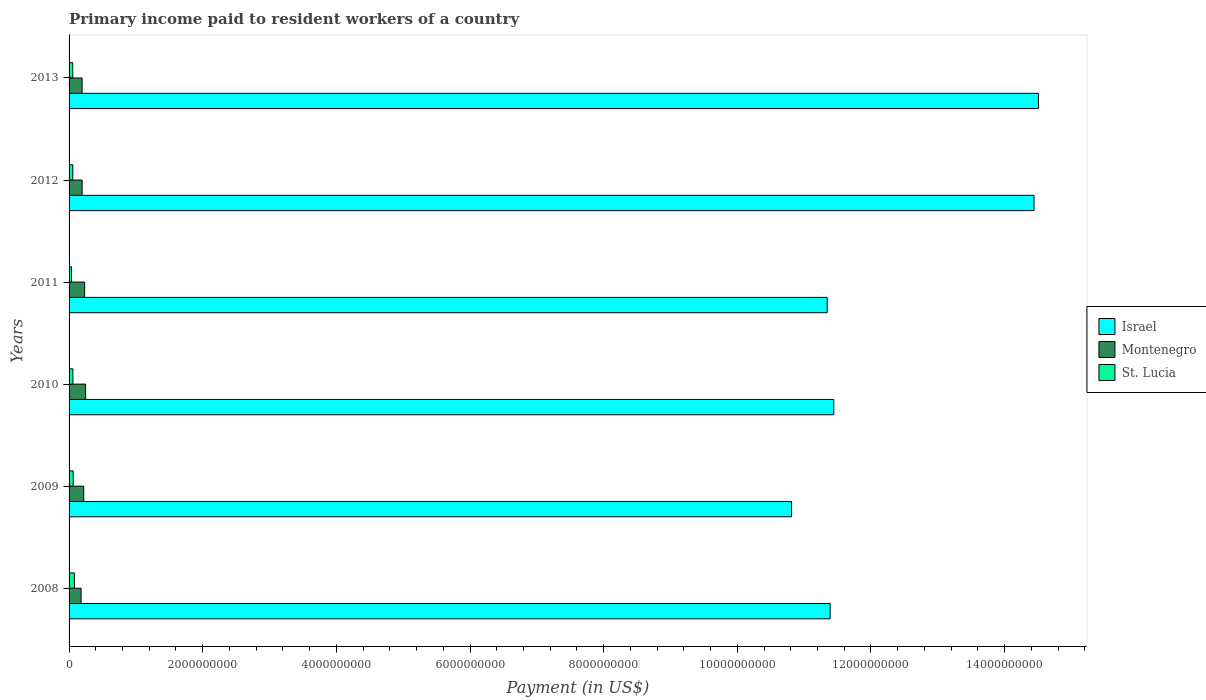How many different coloured bars are there?
Offer a very short reply. 3. How many groups of bars are there?
Your response must be concise. 6. Are the number of bars per tick equal to the number of legend labels?
Give a very brief answer. Yes. Are the number of bars on each tick of the Y-axis equal?
Provide a short and direct response. Yes. How many bars are there on the 3rd tick from the top?
Give a very brief answer. 3. In how many cases, is the number of bars for a given year not equal to the number of legend labels?
Offer a very short reply. 0. What is the amount paid to workers in St. Lucia in 2009?
Your answer should be compact. 6.17e+07. Across all years, what is the maximum amount paid to workers in Montenegro?
Offer a terse response. 2.47e+08. Across all years, what is the minimum amount paid to workers in St. Lucia?
Ensure brevity in your answer.  3.61e+07. In which year was the amount paid to workers in Montenegro maximum?
Offer a terse response. 2010. In which year was the amount paid to workers in St. Lucia minimum?
Give a very brief answer. 2011. What is the total amount paid to workers in St. Lucia in the graph?
Make the answer very short. 3.46e+08. What is the difference between the amount paid to workers in Montenegro in 2008 and that in 2011?
Give a very brief answer. -5.30e+07. What is the difference between the amount paid to workers in St. Lucia in 2011 and the amount paid to workers in Montenegro in 2012?
Provide a short and direct response. -1.59e+08. What is the average amount paid to workers in Israel per year?
Offer a very short reply. 1.23e+1. In the year 2012, what is the difference between the amount paid to workers in Israel and amount paid to workers in St. Lucia?
Give a very brief answer. 1.44e+1. In how many years, is the amount paid to workers in St. Lucia greater than 5600000000 US$?
Your answer should be compact. 0. What is the ratio of the amount paid to workers in Israel in 2011 to that in 2012?
Provide a short and direct response. 0.79. Is the amount paid to workers in St. Lucia in 2010 less than that in 2011?
Provide a short and direct response. No. What is the difference between the highest and the second highest amount paid to workers in St. Lucia?
Provide a short and direct response. 1.84e+07. What is the difference between the highest and the lowest amount paid to workers in Israel?
Your answer should be compact. 3.70e+09. In how many years, is the amount paid to workers in St. Lucia greater than the average amount paid to workers in St. Lucia taken over all years?
Offer a very short reply. 2. Is the sum of the amount paid to workers in Montenegro in 2008 and 2011 greater than the maximum amount paid to workers in St. Lucia across all years?
Make the answer very short. Yes. What does the 2nd bar from the top in 2013 represents?
Provide a succinct answer. Montenegro. What does the 2nd bar from the bottom in 2012 represents?
Your answer should be compact. Montenegro. Is it the case that in every year, the sum of the amount paid to workers in Montenegro and amount paid to workers in St. Lucia is greater than the amount paid to workers in Israel?
Provide a succinct answer. No. How many bars are there?
Ensure brevity in your answer.  18. How many years are there in the graph?
Offer a very short reply. 6. What is the difference between two consecutive major ticks on the X-axis?
Your answer should be very brief. 2.00e+09. Are the values on the major ticks of X-axis written in scientific E-notation?
Ensure brevity in your answer.  No. Does the graph contain any zero values?
Provide a short and direct response. No. Does the graph contain grids?
Your answer should be compact. No. How are the legend labels stacked?
Your response must be concise. Vertical. What is the title of the graph?
Ensure brevity in your answer.  Primary income paid to resident workers of a country. Does "Uruguay" appear as one of the legend labels in the graph?
Keep it short and to the point. No. What is the label or title of the X-axis?
Ensure brevity in your answer.  Payment (in US$). What is the label or title of the Y-axis?
Provide a short and direct response. Years. What is the Payment (in US$) of Israel in 2008?
Provide a short and direct response. 1.14e+1. What is the Payment (in US$) in Montenegro in 2008?
Your response must be concise. 1.80e+08. What is the Payment (in US$) of St. Lucia in 2008?
Offer a terse response. 8.01e+07. What is the Payment (in US$) of Israel in 2009?
Offer a terse response. 1.08e+1. What is the Payment (in US$) in Montenegro in 2009?
Provide a short and direct response. 2.20e+08. What is the Payment (in US$) of St. Lucia in 2009?
Offer a terse response. 6.17e+07. What is the Payment (in US$) of Israel in 2010?
Keep it short and to the point. 1.14e+1. What is the Payment (in US$) of Montenegro in 2010?
Provide a short and direct response. 2.47e+08. What is the Payment (in US$) in St. Lucia in 2010?
Give a very brief answer. 5.73e+07. What is the Payment (in US$) of Israel in 2011?
Give a very brief answer. 1.13e+1. What is the Payment (in US$) of Montenegro in 2011?
Ensure brevity in your answer.  2.33e+08. What is the Payment (in US$) in St. Lucia in 2011?
Offer a very short reply. 3.61e+07. What is the Payment (in US$) in Israel in 2012?
Make the answer very short. 1.44e+1. What is the Payment (in US$) in Montenegro in 2012?
Your response must be concise. 1.95e+08. What is the Payment (in US$) in St. Lucia in 2012?
Ensure brevity in your answer.  5.53e+07. What is the Payment (in US$) in Israel in 2013?
Your answer should be compact. 1.45e+1. What is the Payment (in US$) in Montenegro in 2013?
Your answer should be very brief. 1.95e+08. What is the Payment (in US$) of St. Lucia in 2013?
Your answer should be compact. 5.52e+07. Across all years, what is the maximum Payment (in US$) of Israel?
Your response must be concise. 1.45e+1. Across all years, what is the maximum Payment (in US$) in Montenegro?
Your response must be concise. 2.47e+08. Across all years, what is the maximum Payment (in US$) in St. Lucia?
Give a very brief answer. 8.01e+07. Across all years, what is the minimum Payment (in US$) of Israel?
Ensure brevity in your answer.  1.08e+1. Across all years, what is the minimum Payment (in US$) in Montenegro?
Provide a succinct answer. 1.80e+08. Across all years, what is the minimum Payment (in US$) of St. Lucia?
Your answer should be very brief. 3.61e+07. What is the total Payment (in US$) in Israel in the graph?
Provide a short and direct response. 7.39e+1. What is the total Payment (in US$) in Montenegro in the graph?
Provide a short and direct response. 1.27e+09. What is the total Payment (in US$) in St. Lucia in the graph?
Give a very brief answer. 3.46e+08. What is the difference between the Payment (in US$) in Israel in 2008 and that in 2009?
Offer a very short reply. 5.78e+08. What is the difference between the Payment (in US$) in Montenegro in 2008 and that in 2009?
Keep it short and to the point. -3.97e+07. What is the difference between the Payment (in US$) of St. Lucia in 2008 and that in 2009?
Provide a succinct answer. 1.84e+07. What is the difference between the Payment (in US$) in Israel in 2008 and that in 2010?
Keep it short and to the point. -5.44e+07. What is the difference between the Payment (in US$) in Montenegro in 2008 and that in 2010?
Give a very brief answer. -6.74e+07. What is the difference between the Payment (in US$) of St. Lucia in 2008 and that in 2010?
Your response must be concise. 2.28e+07. What is the difference between the Payment (in US$) in Israel in 2008 and that in 2011?
Provide a short and direct response. 4.39e+07. What is the difference between the Payment (in US$) in Montenegro in 2008 and that in 2011?
Offer a terse response. -5.30e+07. What is the difference between the Payment (in US$) of St. Lucia in 2008 and that in 2011?
Your answer should be very brief. 4.40e+07. What is the difference between the Payment (in US$) in Israel in 2008 and that in 2012?
Your answer should be compact. -3.05e+09. What is the difference between the Payment (in US$) in Montenegro in 2008 and that in 2012?
Provide a short and direct response. -1.53e+07. What is the difference between the Payment (in US$) in St. Lucia in 2008 and that in 2012?
Give a very brief answer. 2.48e+07. What is the difference between the Payment (in US$) of Israel in 2008 and that in 2013?
Your response must be concise. -3.12e+09. What is the difference between the Payment (in US$) of Montenegro in 2008 and that in 2013?
Give a very brief answer. -1.51e+07. What is the difference between the Payment (in US$) in St. Lucia in 2008 and that in 2013?
Your answer should be compact. 2.49e+07. What is the difference between the Payment (in US$) of Israel in 2009 and that in 2010?
Provide a succinct answer. -6.32e+08. What is the difference between the Payment (in US$) of Montenegro in 2009 and that in 2010?
Offer a very short reply. -2.77e+07. What is the difference between the Payment (in US$) in St. Lucia in 2009 and that in 2010?
Your answer should be compact. 4.39e+06. What is the difference between the Payment (in US$) of Israel in 2009 and that in 2011?
Your answer should be compact. -5.34e+08. What is the difference between the Payment (in US$) of Montenegro in 2009 and that in 2011?
Offer a very short reply. -1.33e+07. What is the difference between the Payment (in US$) of St. Lucia in 2009 and that in 2011?
Your answer should be compact. 2.56e+07. What is the difference between the Payment (in US$) of Israel in 2009 and that in 2012?
Make the answer very short. -3.63e+09. What is the difference between the Payment (in US$) in Montenegro in 2009 and that in 2012?
Keep it short and to the point. 2.44e+07. What is the difference between the Payment (in US$) of St. Lucia in 2009 and that in 2012?
Make the answer very short. 6.37e+06. What is the difference between the Payment (in US$) in Israel in 2009 and that in 2013?
Offer a very short reply. -3.70e+09. What is the difference between the Payment (in US$) of Montenegro in 2009 and that in 2013?
Provide a short and direct response. 2.46e+07. What is the difference between the Payment (in US$) of St. Lucia in 2009 and that in 2013?
Provide a succinct answer. 6.50e+06. What is the difference between the Payment (in US$) in Israel in 2010 and that in 2011?
Provide a succinct answer. 9.83e+07. What is the difference between the Payment (in US$) in Montenegro in 2010 and that in 2011?
Give a very brief answer. 1.44e+07. What is the difference between the Payment (in US$) in St. Lucia in 2010 and that in 2011?
Your answer should be compact. 2.12e+07. What is the difference between the Payment (in US$) of Israel in 2010 and that in 2012?
Your answer should be very brief. -3.00e+09. What is the difference between the Payment (in US$) of Montenegro in 2010 and that in 2012?
Offer a very short reply. 5.21e+07. What is the difference between the Payment (in US$) in St. Lucia in 2010 and that in 2012?
Ensure brevity in your answer.  1.98e+06. What is the difference between the Payment (in US$) of Israel in 2010 and that in 2013?
Your answer should be compact. -3.06e+09. What is the difference between the Payment (in US$) of Montenegro in 2010 and that in 2013?
Your response must be concise. 5.23e+07. What is the difference between the Payment (in US$) in St. Lucia in 2010 and that in 2013?
Your answer should be very brief. 2.11e+06. What is the difference between the Payment (in US$) of Israel in 2011 and that in 2012?
Provide a short and direct response. -3.10e+09. What is the difference between the Payment (in US$) in Montenegro in 2011 and that in 2012?
Your answer should be very brief. 3.77e+07. What is the difference between the Payment (in US$) in St. Lucia in 2011 and that in 2012?
Your answer should be compact. -1.92e+07. What is the difference between the Payment (in US$) of Israel in 2011 and that in 2013?
Make the answer very short. -3.16e+09. What is the difference between the Payment (in US$) of Montenegro in 2011 and that in 2013?
Make the answer very short. 3.79e+07. What is the difference between the Payment (in US$) in St. Lucia in 2011 and that in 2013?
Provide a succinct answer. -1.91e+07. What is the difference between the Payment (in US$) of Israel in 2012 and that in 2013?
Your response must be concise. -6.60e+07. What is the difference between the Payment (in US$) of Montenegro in 2012 and that in 2013?
Your response must be concise. 2.12e+05. What is the difference between the Payment (in US$) in St. Lucia in 2012 and that in 2013?
Ensure brevity in your answer.  1.30e+05. What is the difference between the Payment (in US$) of Israel in 2008 and the Payment (in US$) of Montenegro in 2009?
Your answer should be compact. 1.12e+1. What is the difference between the Payment (in US$) of Israel in 2008 and the Payment (in US$) of St. Lucia in 2009?
Give a very brief answer. 1.13e+1. What is the difference between the Payment (in US$) in Montenegro in 2008 and the Payment (in US$) in St. Lucia in 2009?
Offer a terse response. 1.18e+08. What is the difference between the Payment (in US$) of Israel in 2008 and the Payment (in US$) of Montenegro in 2010?
Ensure brevity in your answer.  1.11e+1. What is the difference between the Payment (in US$) of Israel in 2008 and the Payment (in US$) of St. Lucia in 2010?
Provide a succinct answer. 1.13e+1. What is the difference between the Payment (in US$) of Montenegro in 2008 and the Payment (in US$) of St. Lucia in 2010?
Keep it short and to the point. 1.23e+08. What is the difference between the Payment (in US$) of Israel in 2008 and the Payment (in US$) of Montenegro in 2011?
Your answer should be compact. 1.12e+1. What is the difference between the Payment (in US$) in Israel in 2008 and the Payment (in US$) in St. Lucia in 2011?
Offer a very short reply. 1.14e+1. What is the difference between the Payment (in US$) in Montenegro in 2008 and the Payment (in US$) in St. Lucia in 2011?
Offer a very short reply. 1.44e+08. What is the difference between the Payment (in US$) in Israel in 2008 and the Payment (in US$) in Montenegro in 2012?
Offer a very short reply. 1.12e+1. What is the difference between the Payment (in US$) of Israel in 2008 and the Payment (in US$) of St. Lucia in 2012?
Offer a very short reply. 1.13e+1. What is the difference between the Payment (in US$) of Montenegro in 2008 and the Payment (in US$) of St. Lucia in 2012?
Ensure brevity in your answer.  1.25e+08. What is the difference between the Payment (in US$) of Israel in 2008 and the Payment (in US$) of Montenegro in 2013?
Your response must be concise. 1.12e+1. What is the difference between the Payment (in US$) of Israel in 2008 and the Payment (in US$) of St. Lucia in 2013?
Provide a succinct answer. 1.13e+1. What is the difference between the Payment (in US$) of Montenegro in 2008 and the Payment (in US$) of St. Lucia in 2013?
Provide a short and direct response. 1.25e+08. What is the difference between the Payment (in US$) in Israel in 2009 and the Payment (in US$) in Montenegro in 2010?
Give a very brief answer. 1.06e+1. What is the difference between the Payment (in US$) in Israel in 2009 and the Payment (in US$) in St. Lucia in 2010?
Your answer should be compact. 1.08e+1. What is the difference between the Payment (in US$) in Montenegro in 2009 and the Payment (in US$) in St. Lucia in 2010?
Your answer should be very brief. 1.62e+08. What is the difference between the Payment (in US$) of Israel in 2009 and the Payment (in US$) of Montenegro in 2011?
Ensure brevity in your answer.  1.06e+1. What is the difference between the Payment (in US$) in Israel in 2009 and the Payment (in US$) in St. Lucia in 2011?
Give a very brief answer. 1.08e+1. What is the difference between the Payment (in US$) of Montenegro in 2009 and the Payment (in US$) of St. Lucia in 2011?
Your response must be concise. 1.83e+08. What is the difference between the Payment (in US$) of Israel in 2009 and the Payment (in US$) of Montenegro in 2012?
Offer a terse response. 1.06e+1. What is the difference between the Payment (in US$) in Israel in 2009 and the Payment (in US$) in St. Lucia in 2012?
Your answer should be compact. 1.08e+1. What is the difference between the Payment (in US$) in Montenegro in 2009 and the Payment (in US$) in St. Lucia in 2012?
Make the answer very short. 1.64e+08. What is the difference between the Payment (in US$) of Israel in 2009 and the Payment (in US$) of Montenegro in 2013?
Make the answer very short. 1.06e+1. What is the difference between the Payment (in US$) of Israel in 2009 and the Payment (in US$) of St. Lucia in 2013?
Your response must be concise. 1.08e+1. What is the difference between the Payment (in US$) of Montenegro in 2009 and the Payment (in US$) of St. Lucia in 2013?
Give a very brief answer. 1.64e+08. What is the difference between the Payment (in US$) in Israel in 2010 and the Payment (in US$) in Montenegro in 2011?
Your answer should be very brief. 1.12e+1. What is the difference between the Payment (in US$) in Israel in 2010 and the Payment (in US$) in St. Lucia in 2011?
Provide a short and direct response. 1.14e+1. What is the difference between the Payment (in US$) of Montenegro in 2010 and the Payment (in US$) of St. Lucia in 2011?
Make the answer very short. 2.11e+08. What is the difference between the Payment (in US$) in Israel in 2010 and the Payment (in US$) in Montenegro in 2012?
Your response must be concise. 1.12e+1. What is the difference between the Payment (in US$) of Israel in 2010 and the Payment (in US$) of St. Lucia in 2012?
Offer a terse response. 1.14e+1. What is the difference between the Payment (in US$) of Montenegro in 2010 and the Payment (in US$) of St. Lucia in 2012?
Provide a succinct answer. 1.92e+08. What is the difference between the Payment (in US$) in Israel in 2010 and the Payment (in US$) in Montenegro in 2013?
Offer a very short reply. 1.12e+1. What is the difference between the Payment (in US$) of Israel in 2010 and the Payment (in US$) of St. Lucia in 2013?
Provide a succinct answer. 1.14e+1. What is the difference between the Payment (in US$) in Montenegro in 2010 and the Payment (in US$) in St. Lucia in 2013?
Provide a succinct answer. 1.92e+08. What is the difference between the Payment (in US$) of Israel in 2011 and the Payment (in US$) of Montenegro in 2012?
Offer a terse response. 1.12e+1. What is the difference between the Payment (in US$) in Israel in 2011 and the Payment (in US$) in St. Lucia in 2012?
Offer a very short reply. 1.13e+1. What is the difference between the Payment (in US$) in Montenegro in 2011 and the Payment (in US$) in St. Lucia in 2012?
Ensure brevity in your answer.  1.78e+08. What is the difference between the Payment (in US$) of Israel in 2011 and the Payment (in US$) of Montenegro in 2013?
Provide a short and direct response. 1.12e+1. What is the difference between the Payment (in US$) in Israel in 2011 and the Payment (in US$) in St. Lucia in 2013?
Your answer should be compact. 1.13e+1. What is the difference between the Payment (in US$) of Montenegro in 2011 and the Payment (in US$) of St. Lucia in 2013?
Offer a very short reply. 1.78e+08. What is the difference between the Payment (in US$) in Israel in 2012 and the Payment (in US$) in Montenegro in 2013?
Your response must be concise. 1.42e+1. What is the difference between the Payment (in US$) in Israel in 2012 and the Payment (in US$) in St. Lucia in 2013?
Your answer should be compact. 1.44e+1. What is the difference between the Payment (in US$) of Montenegro in 2012 and the Payment (in US$) of St. Lucia in 2013?
Ensure brevity in your answer.  1.40e+08. What is the average Payment (in US$) of Israel per year?
Offer a terse response. 1.23e+1. What is the average Payment (in US$) of Montenegro per year?
Your answer should be very brief. 2.12e+08. What is the average Payment (in US$) of St. Lucia per year?
Give a very brief answer. 5.76e+07. In the year 2008, what is the difference between the Payment (in US$) in Israel and Payment (in US$) in Montenegro?
Ensure brevity in your answer.  1.12e+1. In the year 2008, what is the difference between the Payment (in US$) in Israel and Payment (in US$) in St. Lucia?
Give a very brief answer. 1.13e+1. In the year 2008, what is the difference between the Payment (in US$) in Montenegro and Payment (in US$) in St. Lucia?
Provide a succinct answer. 9.97e+07. In the year 2009, what is the difference between the Payment (in US$) of Israel and Payment (in US$) of Montenegro?
Your answer should be very brief. 1.06e+1. In the year 2009, what is the difference between the Payment (in US$) in Israel and Payment (in US$) in St. Lucia?
Your response must be concise. 1.08e+1. In the year 2009, what is the difference between the Payment (in US$) of Montenegro and Payment (in US$) of St. Lucia?
Provide a short and direct response. 1.58e+08. In the year 2010, what is the difference between the Payment (in US$) in Israel and Payment (in US$) in Montenegro?
Keep it short and to the point. 1.12e+1. In the year 2010, what is the difference between the Payment (in US$) of Israel and Payment (in US$) of St. Lucia?
Your response must be concise. 1.14e+1. In the year 2010, what is the difference between the Payment (in US$) of Montenegro and Payment (in US$) of St. Lucia?
Offer a very short reply. 1.90e+08. In the year 2011, what is the difference between the Payment (in US$) in Israel and Payment (in US$) in Montenegro?
Ensure brevity in your answer.  1.11e+1. In the year 2011, what is the difference between the Payment (in US$) in Israel and Payment (in US$) in St. Lucia?
Give a very brief answer. 1.13e+1. In the year 2011, what is the difference between the Payment (in US$) of Montenegro and Payment (in US$) of St. Lucia?
Ensure brevity in your answer.  1.97e+08. In the year 2012, what is the difference between the Payment (in US$) of Israel and Payment (in US$) of Montenegro?
Make the answer very short. 1.42e+1. In the year 2012, what is the difference between the Payment (in US$) of Israel and Payment (in US$) of St. Lucia?
Offer a very short reply. 1.44e+1. In the year 2012, what is the difference between the Payment (in US$) of Montenegro and Payment (in US$) of St. Lucia?
Keep it short and to the point. 1.40e+08. In the year 2013, what is the difference between the Payment (in US$) of Israel and Payment (in US$) of Montenegro?
Your answer should be compact. 1.43e+1. In the year 2013, what is the difference between the Payment (in US$) of Israel and Payment (in US$) of St. Lucia?
Provide a short and direct response. 1.45e+1. In the year 2013, what is the difference between the Payment (in US$) of Montenegro and Payment (in US$) of St. Lucia?
Ensure brevity in your answer.  1.40e+08. What is the ratio of the Payment (in US$) in Israel in 2008 to that in 2009?
Your answer should be compact. 1.05. What is the ratio of the Payment (in US$) of Montenegro in 2008 to that in 2009?
Provide a succinct answer. 0.82. What is the ratio of the Payment (in US$) of St. Lucia in 2008 to that in 2009?
Offer a terse response. 1.3. What is the ratio of the Payment (in US$) of Montenegro in 2008 to that in 2010?
Your answer should be very brief. 0.73. What is the ratio of the Payment (in US$) of St. Lucia in 2008 to that in 2010?
Your response must be concise. 1.4. What is the ratio of the Payment (in US$) of Montenegro in 2008 to that in 2011?
Provide a succinct answer. 0.77. What is the ratio of the Payment (in US$) in St. Lucia in 2008 to that in 2011?
Offer a very short reply. 2.22. What is the ratio of the Payment (in US$) of Israel in 2008 to that in 2012?
Offer a very short reply. 0.79. What is the ratio of the Payment (in US$) in Montenegro in 2008 to that in 2012?
Provide a short and direct response. 0.92. What is the ratio of the Payment (in US$) of St. Lucia in 2008 to that in 2012?
Keep it short and to the point. 1.45. What is the ratio of the Payment (in US$) of Israel in 2008 to that in 2013?
Ensure brevity in your answer.  0.79. What is the ratio of the Payment (in US$) in Montenegro in 2008 to that in 2013?
Offer a very short reply. 0.92. What is the ratio of the Payment (in US$) in St. Lucia in 2008 to that in 2013?
Your answer should be very brief. 1.45. What is the ratio of the Payment (in US$) in Israel in 2009 to that in 2010?
Keep it short and to the point. 0.94. What is the ratio of the Payment (in US$) of Montenegro in 2009 to that in 2010?
Your answer should be compact. 0.89. What is the ratio of the Payment (in US$) in St. Lucia in 2009 to that in 2010?
Provide a succinct answer. 1.08. What is the ratio of the Payment (in US$) in Israel in 2009 to that in 2011?
Your response must be concise. 0.95. What is the ratio of the Payment (in US$) in Montenegro in 2009 to that in 2011?
Offer a very short reply. 0.94. What is the ratio of the Payment (in US$) of St. Lucia in 2009 to that in 2011?
Provide a short and direct response. 1.71. What is the ratio of the Payment (in US$) of Israel in 2009 to that in 2012?
Offer a very short reply. 0.75. What is the ratio of the Payment (in US$) of Montenegro in 2009 to that in 2012?
Ensure brevity in your answer.  1.12. What is the ratio of the Payment (in US$) of St. Lucia in 2009 to that in 2012?
Offer a terse response. 1.12. What is the ratio of the Payment (in US$) of Israel in 2009 to that in 2013?
Your response must be concise. 0.75. What is the ratio of the Payment (in US$) in Montenegro in 2009 to that in 2013?
Give a very brief answer. 1.13. What is the ratio of the Payment (in US$) in St. Lucia in 2009 to that in 2013?
Your answer should be very brief. 1.12. What is the ratio of the Payment (in US$) of Israel in 2010 to that in 2011?
Your answer should be very brief. 1.01. What is the ratio of the Payment (in US$) of Montenegro in 2010 to that in 2011?
Offer a terse response. 1.06. What is the ratio of the Payment (in US$) in St. Lucia in 2010 to that in 2011?
Your answer should be very brief. 1.59. What is the ratio of the Payment (in US$) in Israel in 2010 to that in 2012?
Provide a short and direct response. 0.79. What is the ratio of the Payment (in US$) in Montenegro in 2010 to that in 2012?
Give a very brief answer. 1.27. What is the ratio of the Payment (in US$) in St. Lucia in 2010 to that in 2012?
Your answer should be very brief. 1.04. What is the ratio of the Payment (in US$) in Israel in 2010 to that in 2013?
Offer a terse response. 0.79. What is the ratio of the Payment (in US$) of Montenegro in 2010 to that in 2013?
Provide a succinct answer. 1.27. What is the ratio of the Payment (in US$) of St. Lucia in 2010 to that in 2013?
Offer a very short reply. 1.04. What is the ratio of the Payment (in US$) in Israel in 2011 to that in 2012?
Provide a succinct answer. 0.79. What is the ratio of the Payment (in US$) of Montenegro in 2011 to that in 2012?
Provide a succinct answer. 1.19. What is the ratio of the Payment (in US$) of St. Lucia in 2011 to that in 2012?
Provide a short and direct response. 0.65. What is the ratio of the Payment (in US$) in Israel in 2011 to that in 2013?
Ensure brevity in your answer.  0.78. What is the ratio of the Payment (in US$) in Montenegro in 2011 to that in 2013?
Your answer should be very brief. 1.19. What is the ratio of the Payment (in US$) of St. Lucia in 2011 to that in 2013?
Offer a terse response. 0.65. What is the ratio of the Payment (in US$) in Israel in 2012 to that in 2013?
Your answer should be very brief. 1. What is the ratio of the Payment (in US$) in Montenegro in 2012 to that in 2013?
Offer a very short reply. 1. What is the difference between the highest and the second highest Payment (in US$) of Israel?
Provide a short and direct response. 6.60e+07. What is the difference between the highest and the second highest Payment (in US$) in Montenegro?
Ensure brevity in your answer.  1.44e+07. What is the difference between the highest and the second highest Payment (in US$) in St. Lucia?
Your response must be concise. 1.84e+07. What is the difference between the highest and the lowest Payment (in US$) of Israel?
Your answer should be compact. 3.70e+09. What is the difference between the highest and the lowest Payment (in US$) of Montenegro?
Provide a succinct answer. 6.74e+07. What is the difference between the highest and the lowest Payment (in US$) of St. Lucia?
Your answer should be compact. 4.40e+07. 